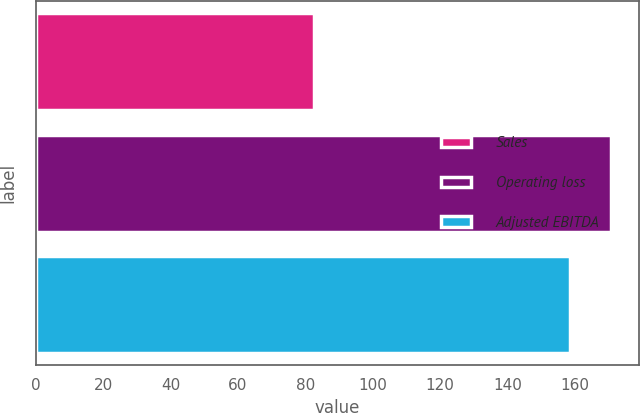Convert chart. <chart><loc_0><loc_0><loc_500><loc_500><bar_chart><fcel>Sales<fcel>Operating loss<fcel>Adjusted EBITDA<nl><fcel>82.6<fcel>170.6<fcel>158.4<nl></chart> 